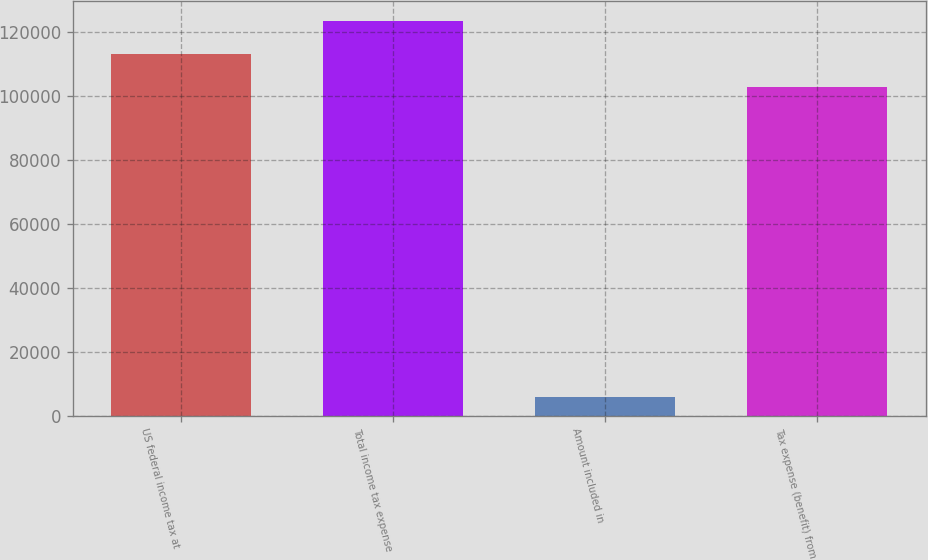Convert chart. <chart><loc_0><loc_0><loc_500><loc_500><bar_chart><fcel>US federal income tax at<fcel>Total income tax expense<fcel>Amount included in<fcel>Tax expense (benefit) from<nl><fcel>113332<fcel>123635<fcel>5732<fcel>103029<nl></chart> 